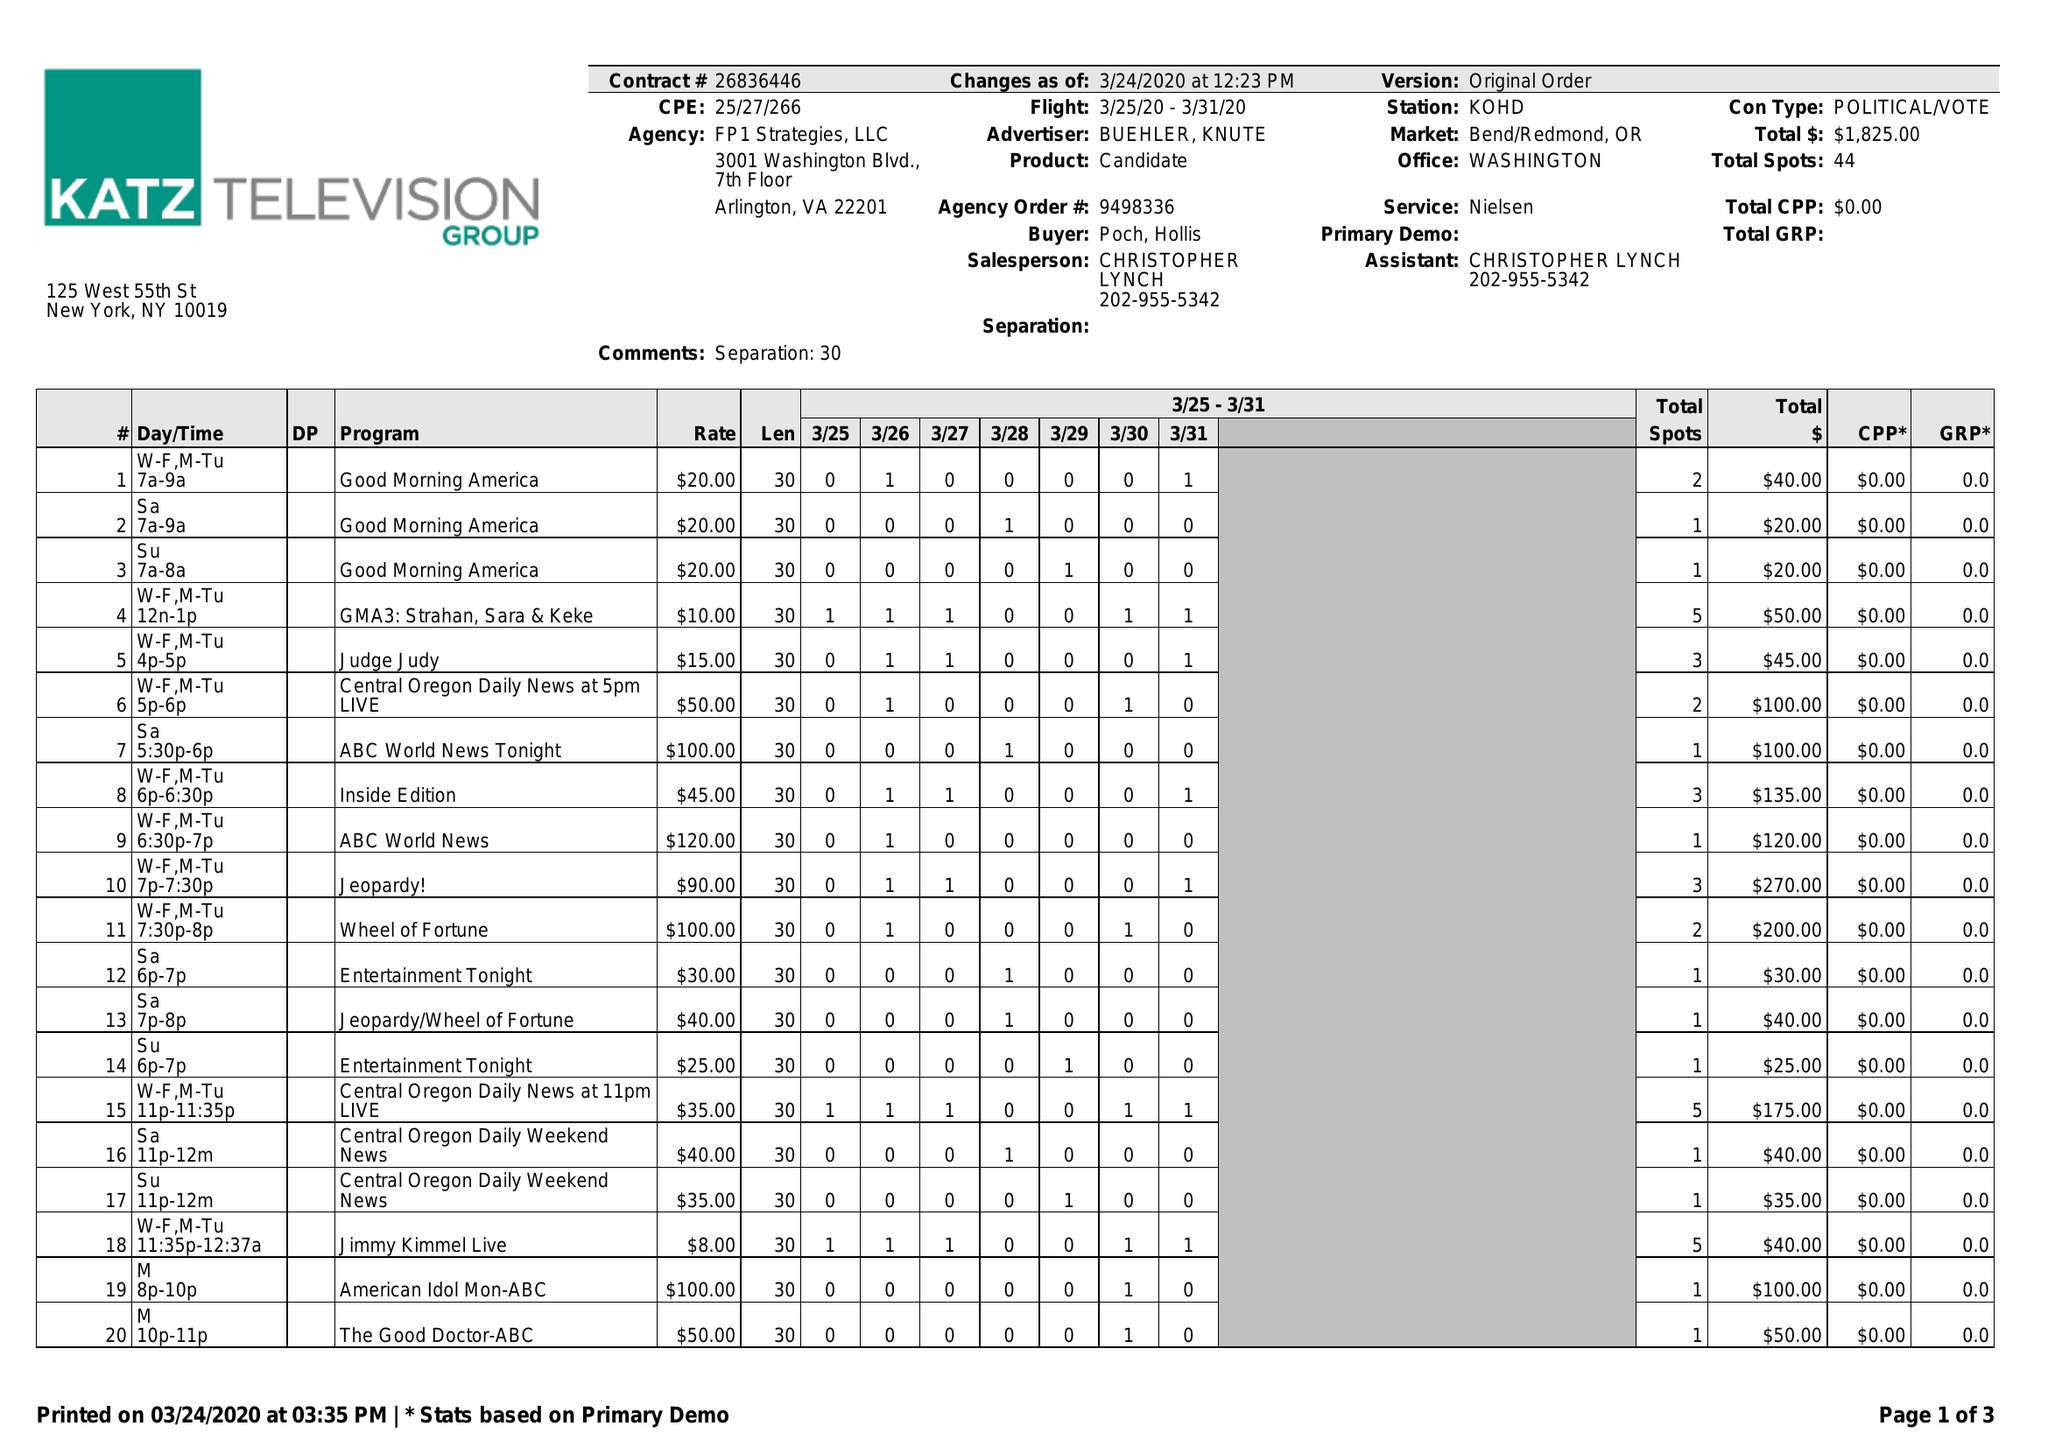What is the value for the advertiser?
Answer the question using a single word or phrase. BUEHLER, KNUTE 